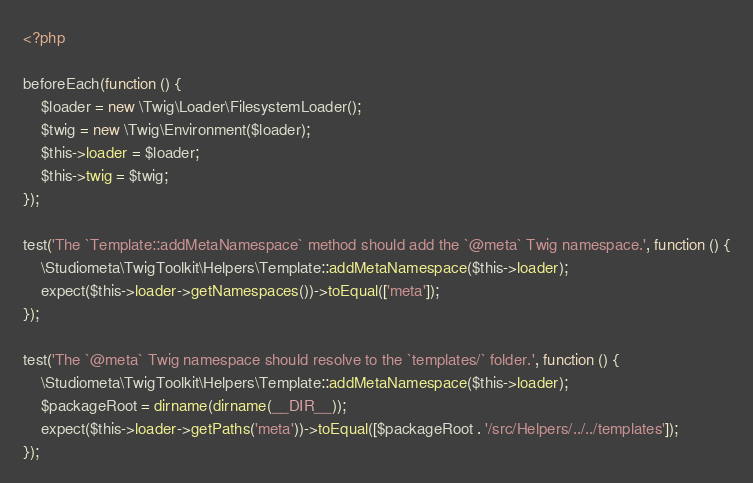<code> <loc_0><loc_0><loc_500><loc_500><_PHP_><?php

beforeEach(function () {
    $loader = new \Twig\Loader\FilesystemLoader();
    $twig = new \Twig\Environment($loader);
    $this->loader = $loader;
    $this->twig = $twig;
});

test('The `Template::addMetaNamespace` method should add the `@meta` Twig namespace.', function () {
    \Studiometa\TwigToolkit\Helpers\Template::addMetaNamespace($this->loader);
    expect($this->loader->getNamespaces())->toEqual(['meta']);
});

test('The `@meta` Twig namespace should resolve to the `templates/` folder.', function () {
    \Studiometa\TwigToolkit\Helpers\Template::addMetaNamespace($this->loader);
    $packageRoot = dirname(dirname(__DIR__));
    expect($this->loader->getPaths('meta'))->toEqual([$packageRoot . '/src/Helpers/../../templates']);
});
</code> 